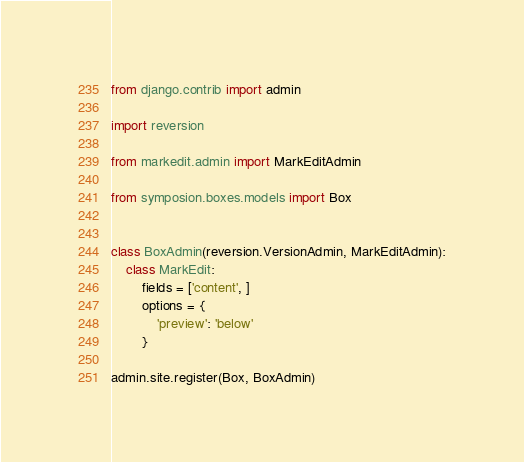Convert code to text. <code><loc_0><loc_0><loc_500><loc_500><_Python_>from django.contrib import admin

import reversion

from markedit.admin import MarkEditAdmin

from symposion.boxes.models import Box


class BoxAdmin(reversion.VersionAdmin, MarkEditAdmin):
    class MarkEdit:
        fields = ['content', ]
        options = {
            'preview': 'below'
        }

admin.site.register(Box, BoxAdmin)
</code> 